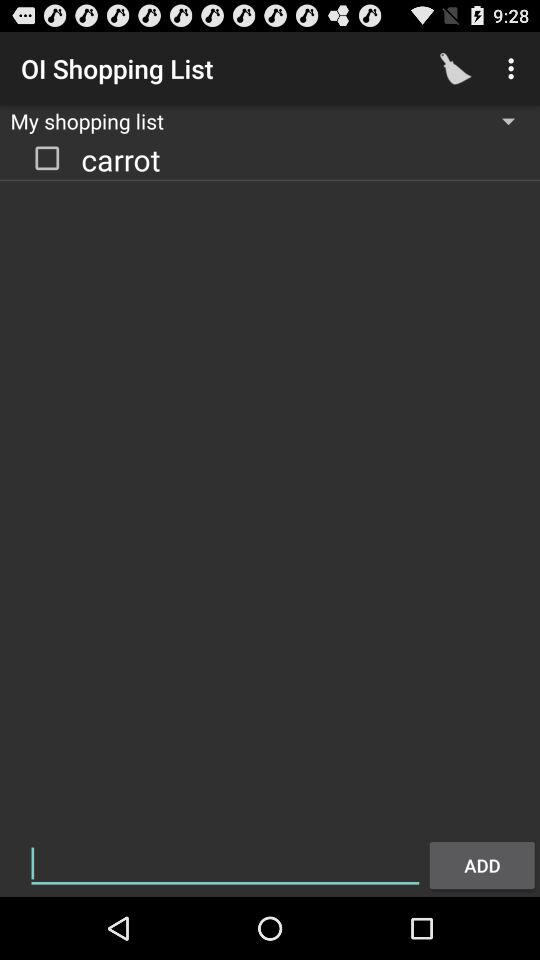What items are there on the shopping list? The item that is on the shopping list is "carrot". 